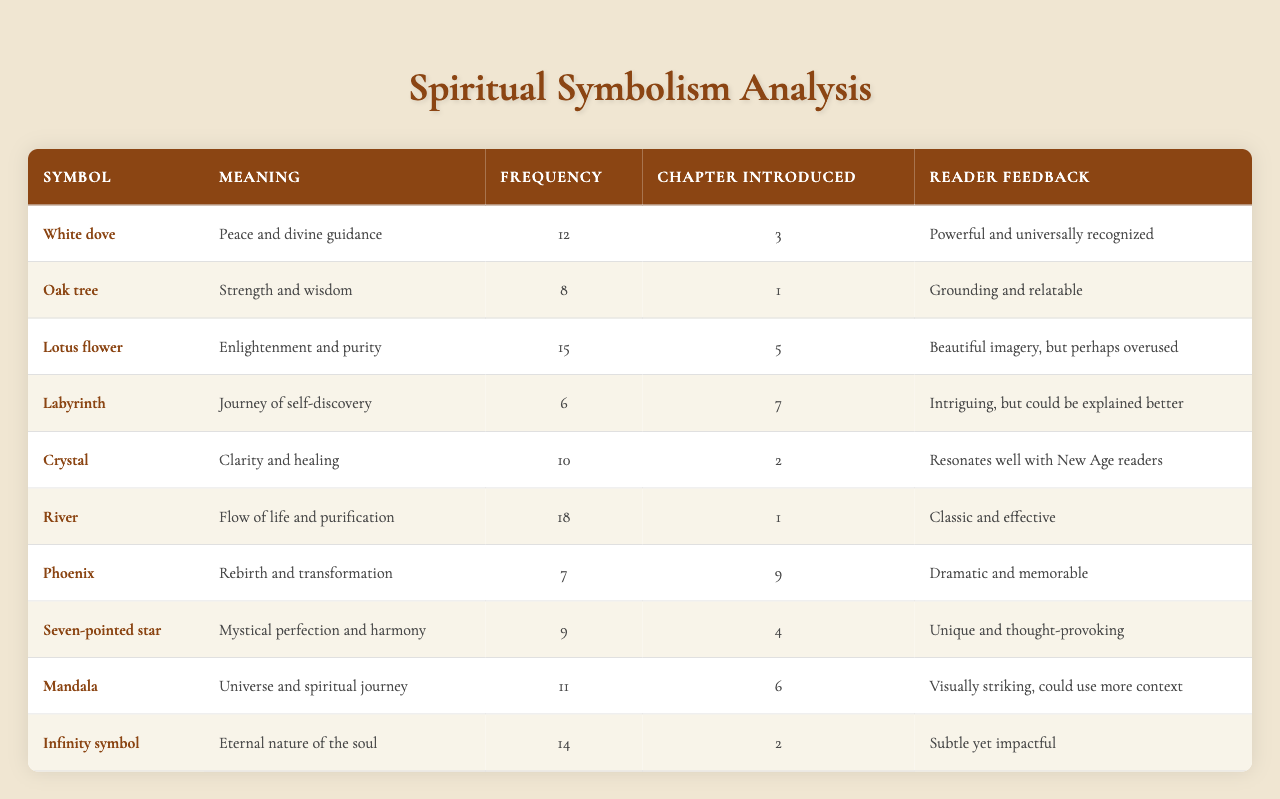What is the meaning of the white dove symbol? According to the table, the white dove symbolizes peace and divine guidance.
Answer: Peace and divine guidance How many times is the lotus flower mentioned in the novel? The frequency column indicates that the lotus flower is mentioned 15 times in the novel.
Answer: 15 In which chapter is the river introduced? The chapter introduced column shows that the river symbol is introduced in chapter 1.
Answer: Chapter 1 Which symbol has the highest frequency? By comparing the frequency values, the river has the highest frequency at 18 mentions.
Answer: River What is the meaning associated with the seven-pointed star? The table lists the seven-pointed star as representing mystical perfection and harmony.
Answer: Mystical perfection and harmony Is the phoenix symbol mentioned more than the oak tree? The frequency for the phoenix is 7, while the oak tree's frequency is 8. Therefore, the phoenix is not mentioned more.
Answer: No What is the average frequency of the symbols mentioned? To find the average, sum the frequencies (12 + 8 + 15 + 6 + 10 + 18 + 7 + 9 + 11 + 14 = 120) and divide by the total count (10), giving an average of 12.
Answer: 12 How many symbols were introduced in chapters 2 and 3? From the chapter introduced column, the symbols introduced in chapter 2 are the crystal and the infinity symbol (2 symbols), and in chapter 3 only the white dove (1 symbol). Together, that makes a total of 3 symbols.
Answer: 3 Which symbol received feedback that it resonates well with New Age readers? The table indicates that the crystal symbol received the feedback of resonating well with New Age readers.
Answer: Crystal What is the relationship between the frequency of the oak tree and the phoenix? The oak tree has a frequency of 8, while the phoenix has a frequency of 7, indicating that the oak tree is mentioned one more time than the phoenix.
Answer: Oak tree is mentioned once more than the phoenix 